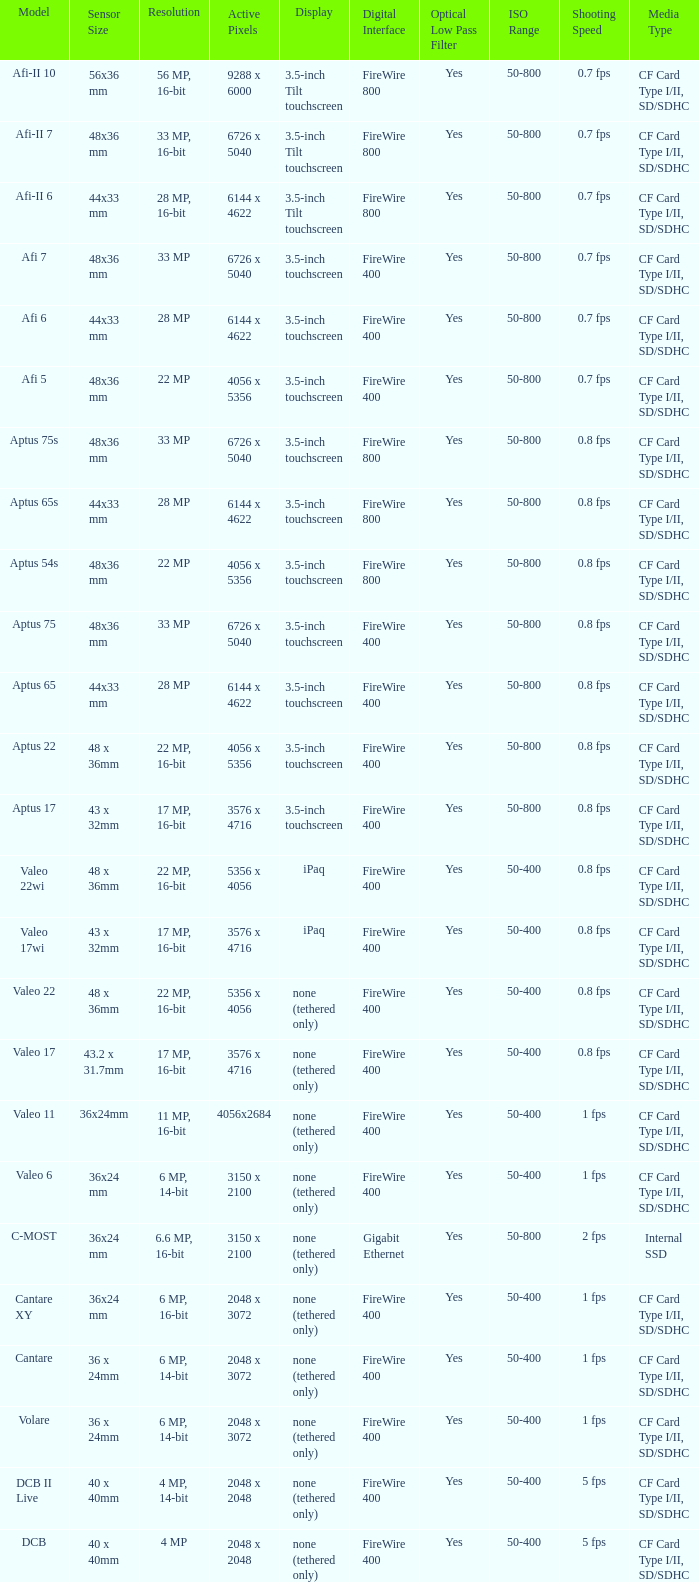What is the resolution of the camera that has 6726 x 5040 pixels and a model of afi 7? 33 MP. 